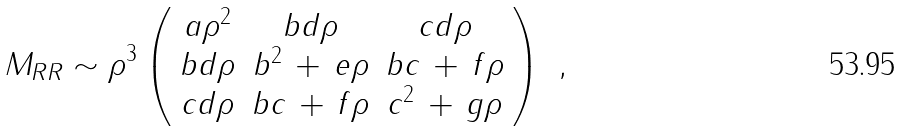Convert formula to latex. <formula><loc_0><loc_0><loc_500><loc_500>M _ { R R } \sim \rho ^ { 3 } \left ( \begin{array} { c c c } a \rho ^ { 2 } & b d \rho & c d \rho \\ b d \rho & b ^ { 2 } \, + \, e \rho & b c \, + \, f \rho \\ c d \rho & b c \, + \, f \rho & c ^ { 2 } \, + \, g \rho \end{array} \right ) \ ,</formula> 